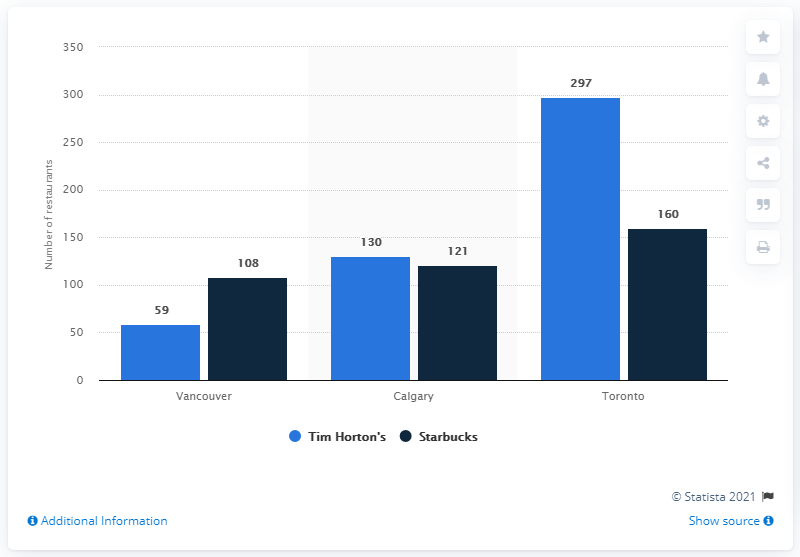Can you explain what this chart is showing? Certainly! The chart depicts a comparison between the number of Tim Hortons and Starbucks locations in three Canadian cities: Vancouver, Calgary, and Toronto. The light blue bars represent Tim Hortons, while the dark blue bars stand for Starbucks. Each pair of bars corresponds to a different city, showing the count of establishments for each coffee chain. 